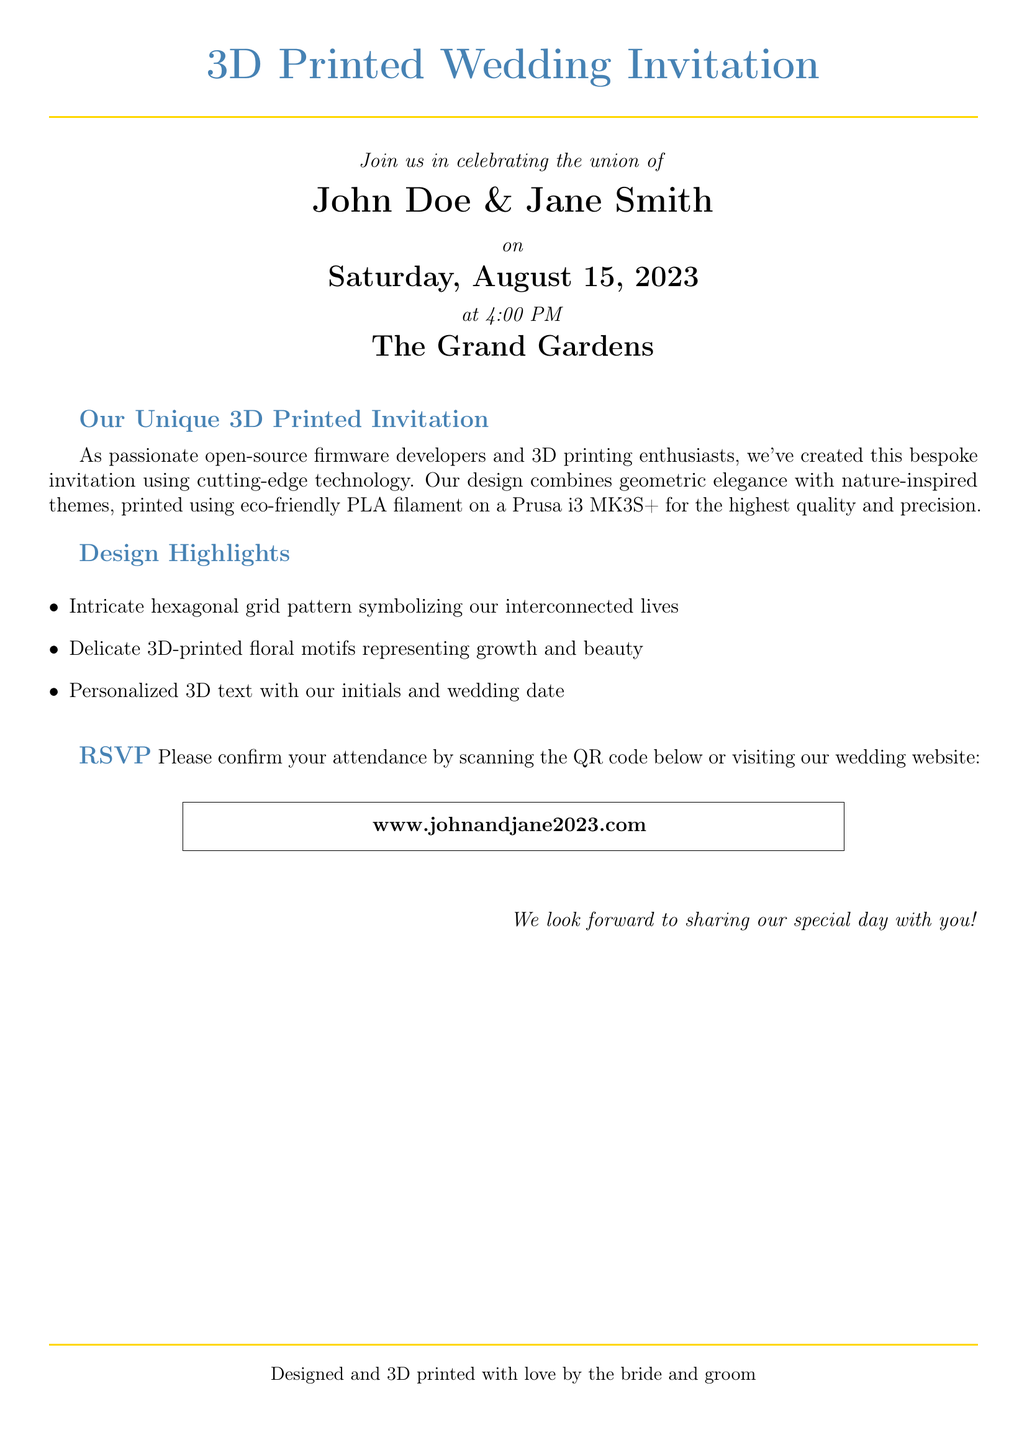What is the full name of the couple? The document states the names of the couple celebrating their union, which are John Doe and Jane Smith.
Answer: John Doe & Jane Smith What is the date of the wedding? The invitation specifies the date of the wedding, which is Saturday, August 15, 2023.
Answer: August 15, 2023 What time does the wedding start? The document indicates the starting time of the wedding event, which is 4:00 PM.
Answer: 4:00 PM What is the venue for the wedding? The document mentions the location where the wedding will take place, which is The Grand Gardens.
Answer: The Grand Gardens What motif do the 3D-printed designs represent? The document elaborates on the themes represented by the floral motifs, which symbolize growth and beauty.
Answer: Growth and beauty What type of filament was used for printing the invitation? The text describes the material used for printing, which is eco-friendly PLA filament.
Answer: PLA filament What is unique about the invitation? The document emphasizes that the invitation was created using cutting-edge technology and 3D printing, which makes it bespoke.
Answer: Bespoke design What should guests do to RSVP? The invitation indicates that guests can confirm their attendance by scanning a QR code or visiting the wedding website.
Answer: Scan the QR code or visit the website Who designed the wedding invitation? The document attributes the design of the invitation to the bride and groom, specifically highlighting their involvement.
Answer: The bride and groom 